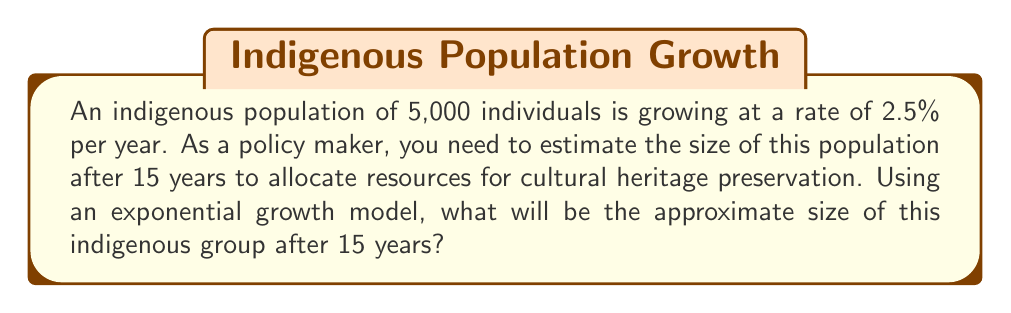Solve this math problem. To solve this problem, we'll use the exponential growth formula:

$$A = P(1 + r)^t$$

Where:
$A$ = Final amount
$P$ = Initial population
$r$ = Growth rate (as a decimal)
$t$ = Time in years

Given:
$P = 5,000$
$r = 2.5\% = 0.025$
$t = 15$ years

Step 1: Plug the values into the formula
$$A = 5,000(1 + 0.025)^{15}$$

Step 2: Simplify the expression inside the parentheses
$$A = 5,000(1.025)^{15}$$

Step 3: Calculate the exponent
$$(1.025)^{15} \approx 1.4477$$

Step 4: Multiply by the initial population
$$A = 5,000 \times 1.4477 \approx 7,238.5$$

Step 5: Round to the nearest whole number, as we're dealing with people
$$A \approx 7,239$$
Answer: 7,239 individuals 